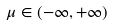<formula> <loc_0><loc_0><loc_500><loc_500>\mu \in ( - \infty , + \infty )</formula> 